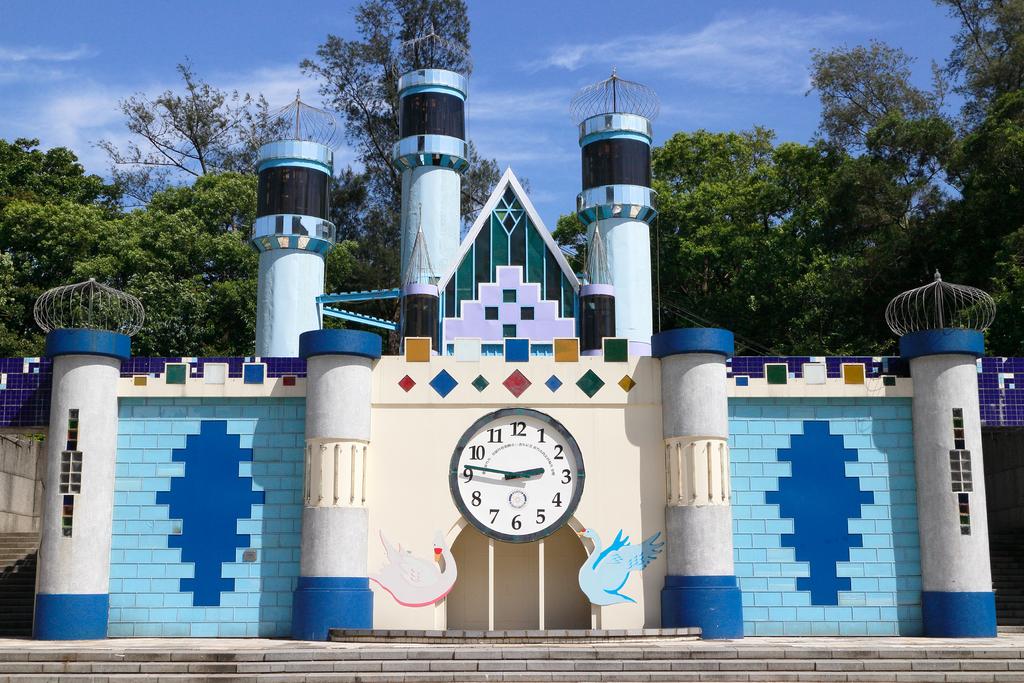How long will it take for the clock to change the hour?
Your response must be concise. 14 minutes. Whattime is on the clock?
Keep it short and to the point. 2:47. 